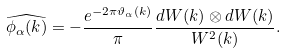<formula> <loc_0><loc_0><loc_500><loc_500>\widehat { \phi _ { \alpha } ( k ) } = - \frac { e ^ { - 2 \pi \vartheta _ { \alpha } ( k ) } } { \pi } \frac { d W ( k ) \otimes d W ( k ) } { W ^ { 2 } ( k ) } .</formula> 